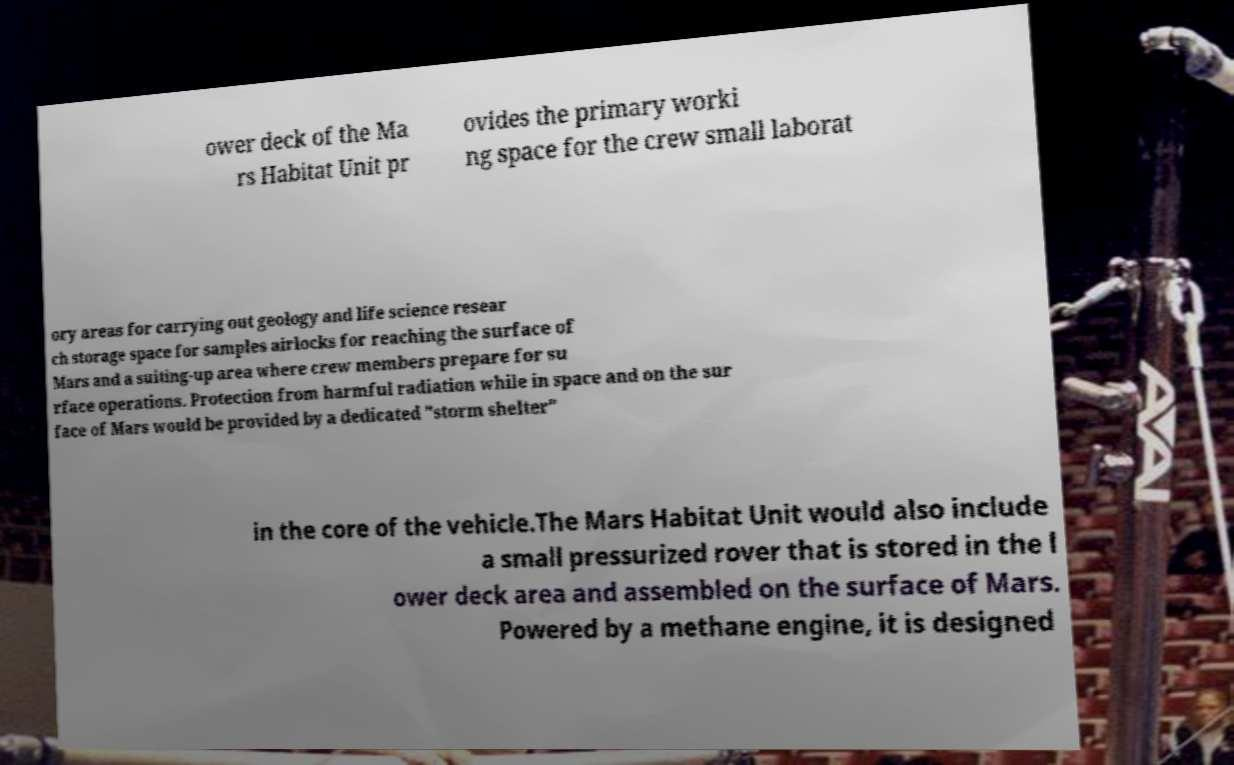For documentation purposes, I need the text within this image transcribed. Could you provide that? ower deck of the Ma rs Habitat Unit pr ovides the primary worki ng space for the crew small laborat ory areas for carrying out geology and life science resear ch storage space for samples airlocks for reaching the surface of Mars and a suiting-up area where crew members prepare for su rface operations. Protection from harmful radiation while in space and on the sur face of Mars would be provided by a dedicated "storm shelter" in the core of the vehicle.The Mars Habitat Unit would also include a small pressurized rover that is stored in the l ower deck area and assembled on the surface of Mars. Powered by a methane engine, it is designed 